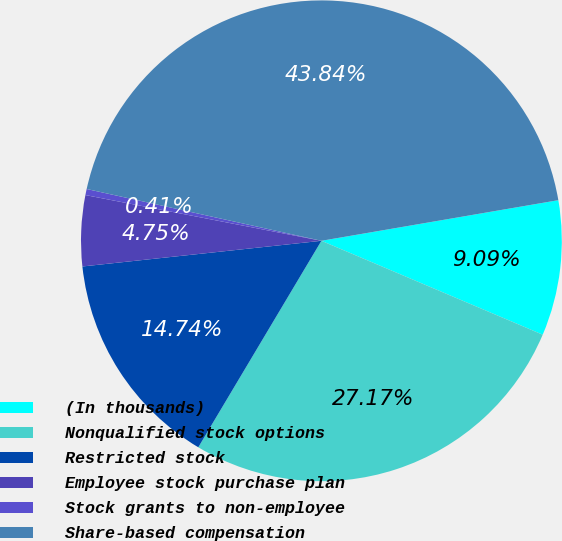Convert chart to OTSL. <chart><loc_0><loc_0><loc_500><loc_500><pie_chart><fcel>(In thousands)<fcel>Nonqualified stock options<fcel>Restricted stock<fcel>Employee stock purchase plan<fcel>Stock grants to non-employee<fcel>Share-based compensation<nl><fcel>9.09%<fcel>27.17%<fcel>14.74%<fcel>4.75%<fcel>0.41%<fcel>43.84%<nl></chart> 